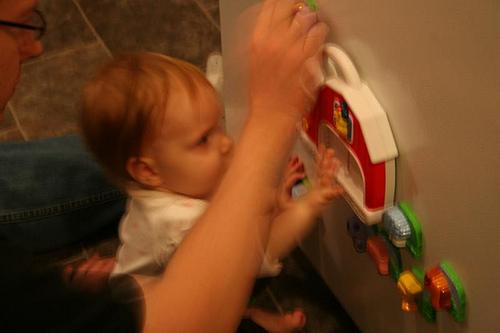Is it someone's birthday?
Concise answer only. No. Is this a bathroom or kitchen?
Quick response, please. Kitchen. Is the baby sitting on the floor?
Write a very short answer. Yes. What type of building is the toy?
Keep it brief. Barn. What color shirt is the girl wearing?
Answer briefly. White. What holiday has the room featured in the picture been prepared for?
Be succinct. Christmas. Who is with the baby?
Quick response, please. Adult. Does the girl have long hair?
Quick response, please. No. 